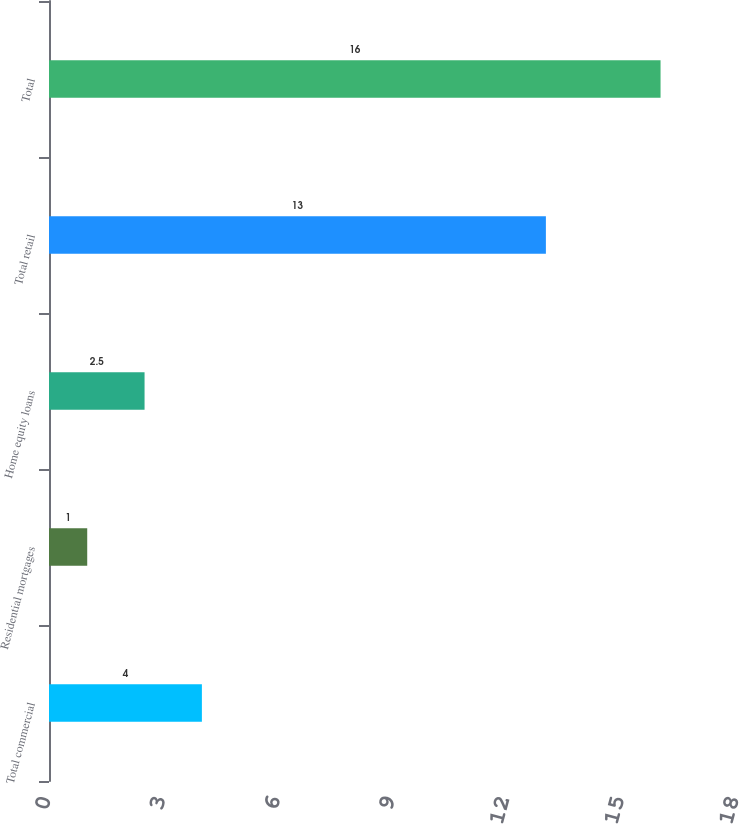Convert chart to OTSL. <chart><loc_0><loc_0><loc_500><loc_500><bar_chart><fcel>Total commercial<fcel>Residential mortgages<fcel>Home equity loans<fcel>Total retail<fcel>Total<nl><fcel>4<fcel>1<fcel>2.5<fcel>13<fcel>16<nl></chart> 